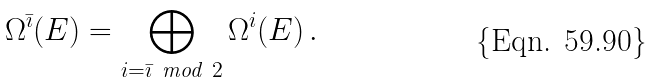Convert formula to latex. <formula><loc_0><loc_0><loc_500><loc_500>\Omega ^ { \bar { \imath } } ( E ) = \bigoplus _ { i = \bar { \imath } \ \text {mod} \ 2 } \Omega ^ { i } ( E ) \, .</formula> 